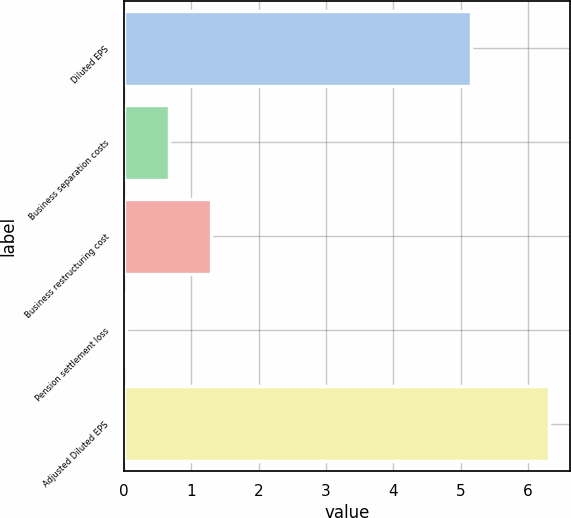<chart> <loc_0><loc_0><loc_500><loc_500><bar_chart><fcel>Diluted EPS<fcel>Business separation costs<fcel>Business restructuring cost<fcel>Pension settlement loss<fcel>Adjusted Diluted EPS<nl><fcel>5.16<fcel>0.66<fcel>1.29<fcel>0.03<fcel>6.31<nl></chart> 